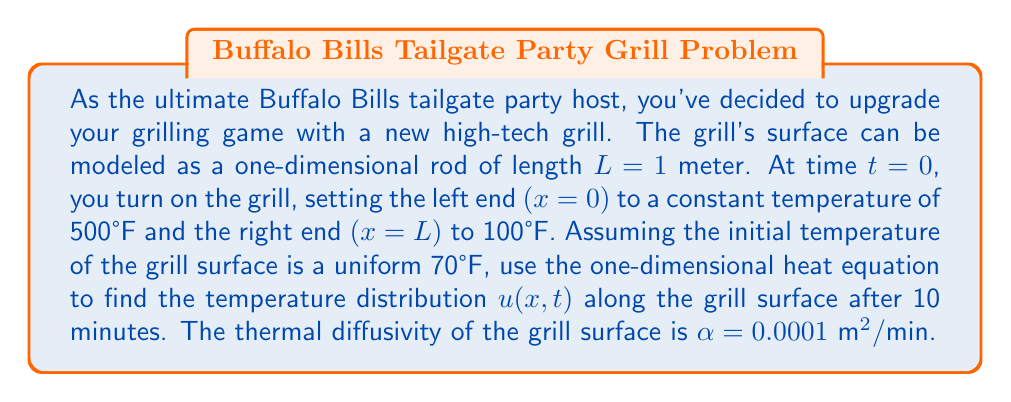Can you solve this math problem? To solve this problem, we'll use the one-dimensional heat equation:

$$\frac{\partial u}{\partial t} = \alpha \frac{\partial^2 u}{\partial x^2}$$

With the following initial and boundary conditions:

1. Initial condition: $u(x,0) = 70$ for $0 < x < L$
2. Boundary conditions: $u(0,t) = 500$ and $u(L,t) = 100$ for $t > 0$

We can solve this using the separation of variables method:

1) Assume $u(x,t) = X(x)T(t)$

2) Substituting into the heat equation:

   $$X(x)T'(t) = \alpha X''(x)T(t)$$

3) Separating variables:

   $$\frac{T'(t)}{T(t)} = \alpha \frac{X''(x)}{X(x)} = -\lambda$$

4) This gives us two ordinary differential equations:

   $$T'(t) = -\lambda \alpha T(t)$$
   $$X''(x) = -\lambda X(x)$$

5) The general solutions are:

   $$T(t) = Ae^{-\lambda \alpha t}$$
   $$X(x) = B\sin(\sqrt{\lambda}x) + C\cos(\sqrt{\lambda}x)$$

6) Applying the boundary conditions:

   $X(0) = 0$ implies $C = 0$
   $X(L) = 0$ implies $\sin(\sqrt{\lambda}L) = 0$

   This gives us $\lambda_n = (\frac{n\pi}{L})^2$ for $n = 1,2,3,...$

7) The general solution is:

   $$u(x,t) = \sum_{n=1}^{\infty} A_n \sin(\frac{n\pi x}{L})e^{-(\frac{n\pi}{L})^2\alpha t}$$

8) To satisfy the boundary conditions, we add the steady-state solution:

   $$u_s(x) = 500 - 400\frac{x}{L}$$

9) The complete solution is:

   $$u(x,t) = 500 - 400\frac{x}{L} + \sum_{n=1}^{\infty} A_n \sin(\frac{n\pi x}{L})e^{-(\frac{n\pi}{L})^2\alpha t}$$

10) Using the initial condition to find $A_n$:

    $$70 = 500 - 400\frac{x}{L} + \sum_{n=1}^{\infty} A_n \sin(\frac{n\pi x}{L})$$

11) Multiplying both sides by $\sin(\frac{m\pi x}{L})$ and integrating from 0 to L:

    $$A_n = \frac{2}{L}\int_0^L (70 - 500 + 400\frac{x}{L})\sin(\frac{n\pi x}{L})dx = \frac{800}{n\pi}(\cos(n\pi)-1)$$

12) The final solution is:

    $$u(x,t) = 500 - 400\frac{x}{L} + \sum_{n=1}^{\infty} \frac{800}{n\pi}(\cos(n\pi)-1) \sin(\frac{n\pi x}{L})e^{-(\frac{n\pi}{L})^2\alpha t}$$

13) For $t = 10$ minutes, $L = 1$ meter, and $\alpha = 0.0001 \text{ m}^2/\text{min}$, we can evaluate this series numerically to find the temperature distribution.
Answer: The temperature distribution $u(x,10)$ along the grill surface after 10 minutes is given by:

$$u(x,10) = 500 - 400x + \sum_{n=1}^{\infty} \frac{800}{n\pi}(\cos(n\pi)-1) \sin(n\pi x)e^{-(n\pi)^2(0.001)}$$

This series converges rapidly, and can be evaluated numerically for specific values of $x$ to determine the temperature at any point along the grill surface. 